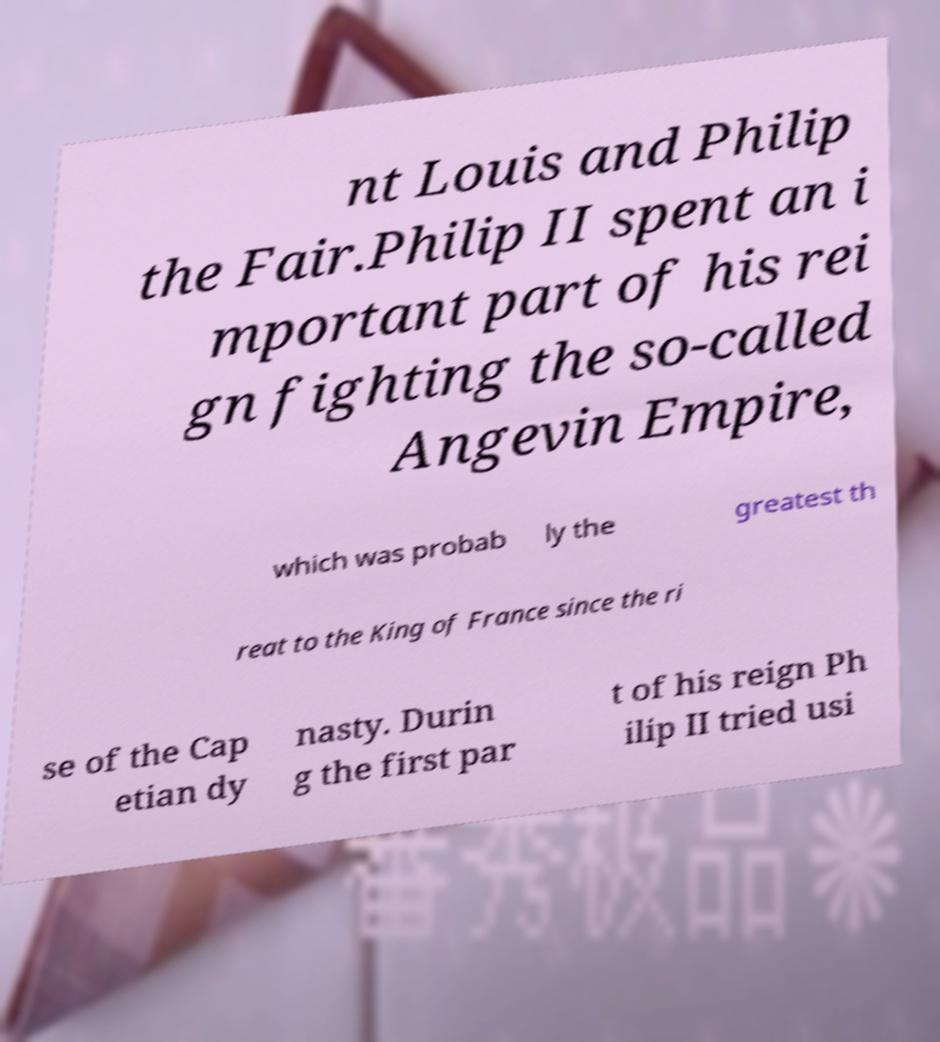Can you read and provide the text displayed in the image?This photo seems to have some interesting text. Can you extract and type it out for me? nt Louis and Philip the Fair.Philip II spent an i mportant part of his rei gn fighting the so-called Angevin Empire, which was probab ly the greatest th reat to the King of France since the ri se of the Cap etian dy nasty. Durin g the first par t of his reign Ph ilip II tried usi 